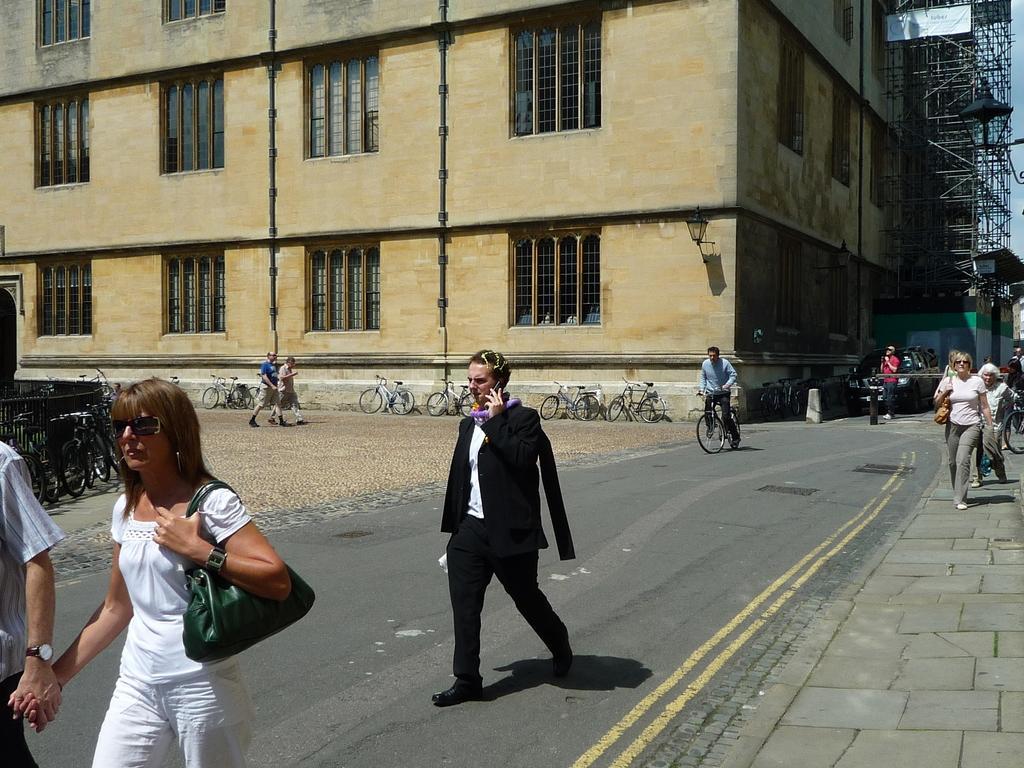How would you summarize this image in a sentence or two? In this image we can see people walking on the road. There is a person riding a bicycle. In the background of the image there is a building with windows. There are bicycles. To the right side of the image there are rods. At the bottom of the image there is pavement. 